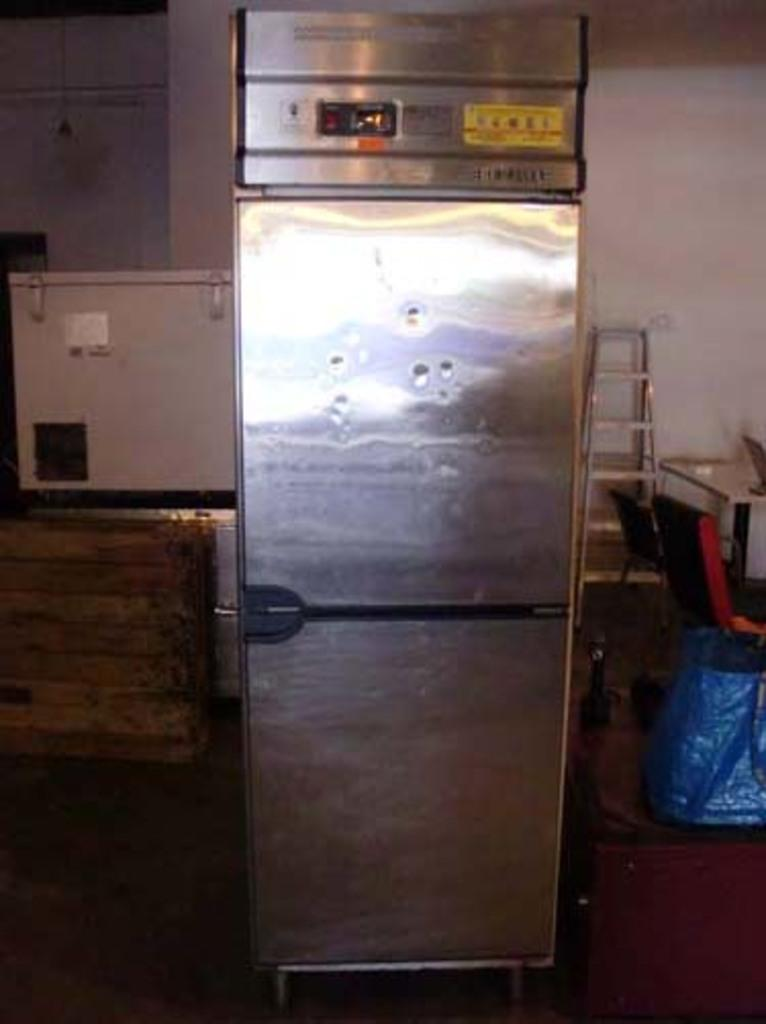<image>
Describe the image concisely. A picture of a fridge, with no discernible text in it. 